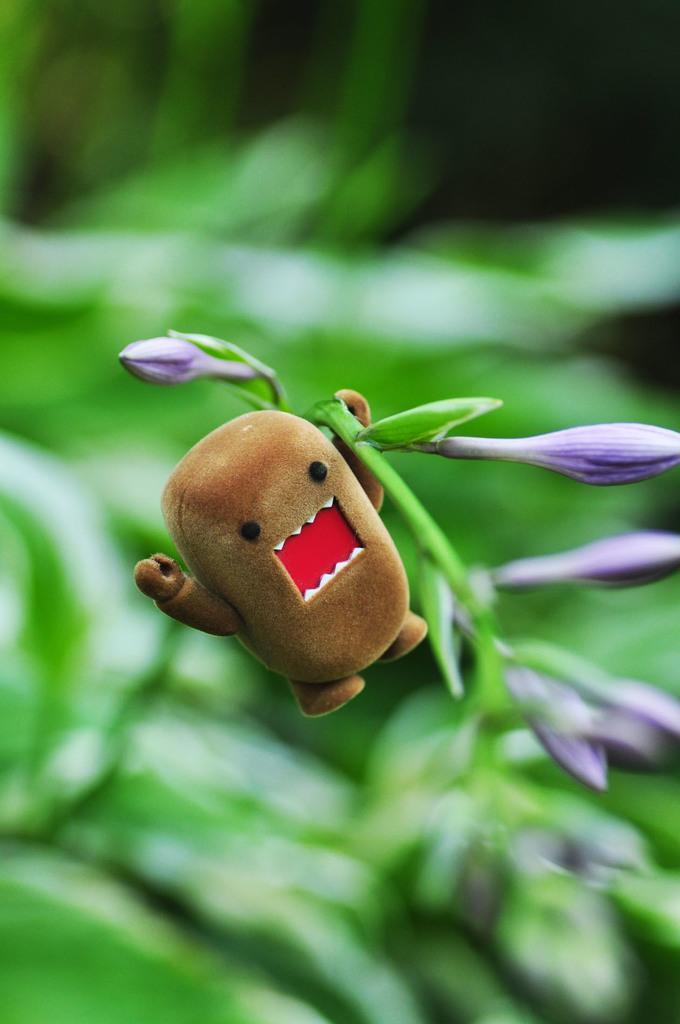In one or two sentences, can you explain what this image depicts? In this image I can see few flower buds and a brown colour thing in the centre. I can also see this image is blurry in the background. 